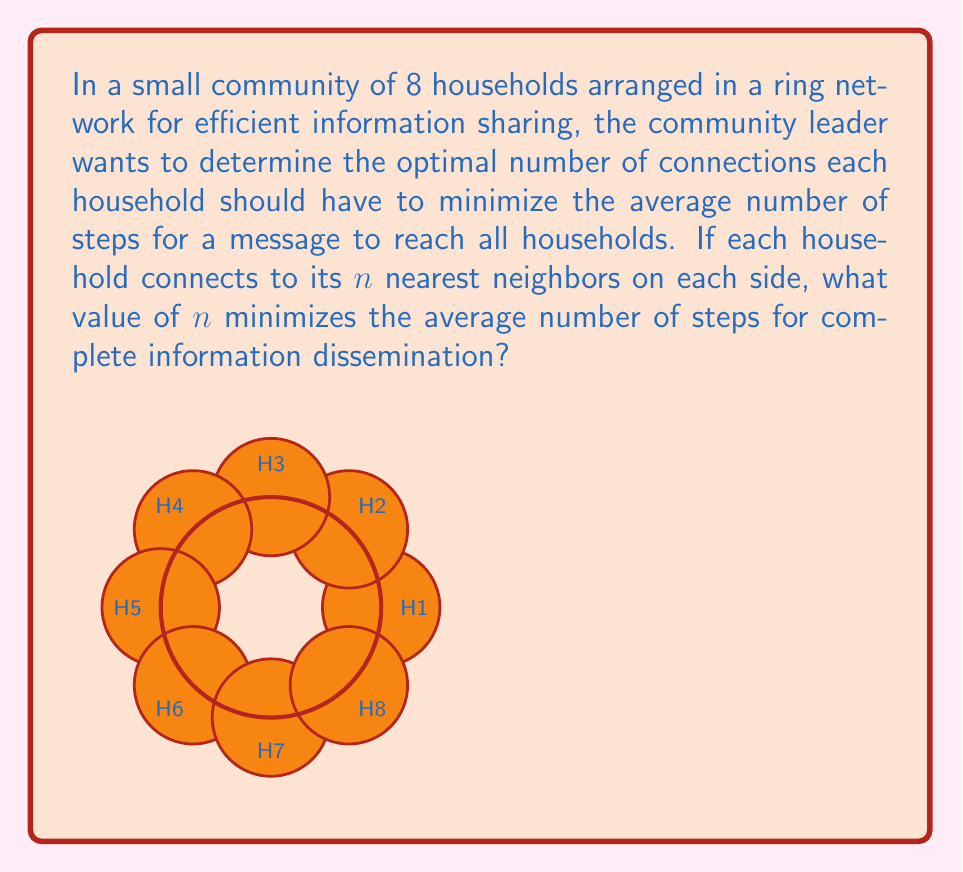Help me with this question. Let's approach this step-by-step:

1) In a ring network with 8 households, each household connecting to $n$ neighbors on each side means it has $2n$ total connections.

2) The maximum number of steps a message needs to travel is $(4-n)$ when $n < 4$, and 1 when $n \geq 4$.

3) The average number of steps can be calculated as:

   $$\text{Avg steps} = \frac{\sum_{i=1}^{4-n} i \cdot 2}{8} \text{ for } n < 4$$
   $$\text{Avg steps} = 1 \text{ for } n \geq 4$$

4) Let's calculate for different values of $n$:

   For $n = 1$:
   $$\text{Avg steps} = \frac{1 \cdot 2 + 2 \cdot 2 + 3 \cdot 2}{8} = \frac{12}{8} = 1.5$$

   For $n = 2$:
   $$\text{Avg steps} = \frac{1 \cdot 2 + 2 \cdot 2}{8} = \frac{6}{8} = 0.75$$

   For $n = 3$:
   $$\text{Avg steps} = \frac{1 \cdot 2}{8} = \frac{2}{8} = 0.25$$

   For $n \geq 4$:
   $$\text{Avg steps} = 1$$

5) The minimum average number of steps is achieved when $n = 3$.

This solution balances efficiency (quick information dissemination) with practicality (not overwhelming each household with too many connections).
Answer: $n = 3$ 